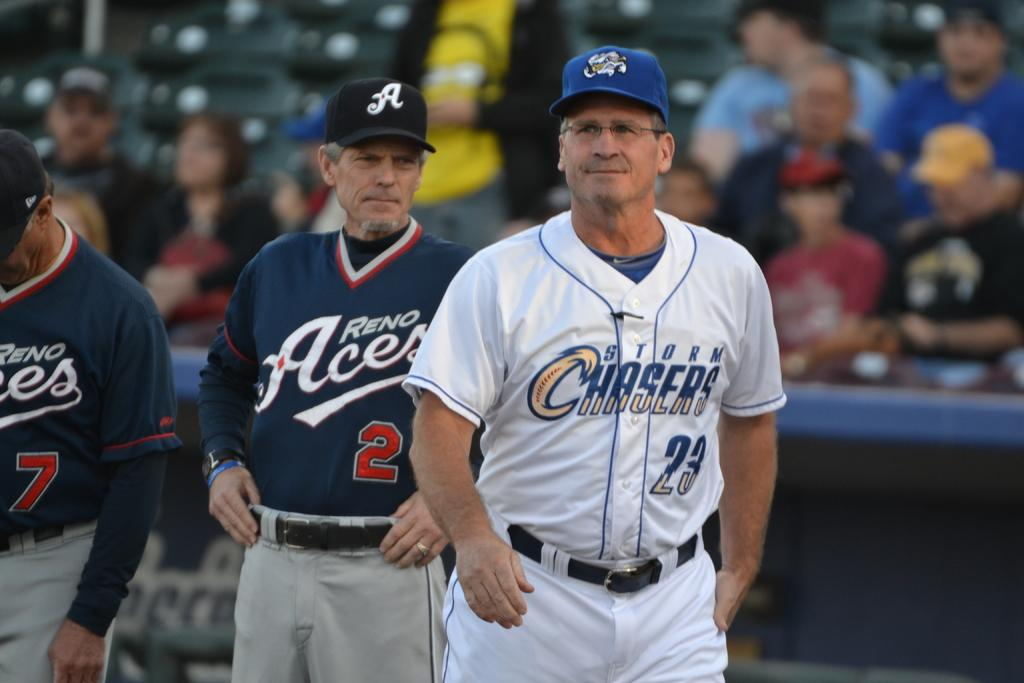<image>
Summarize the visual content of the image. people in sports uniforms for Reno Aces and Storm Chasers on a field 